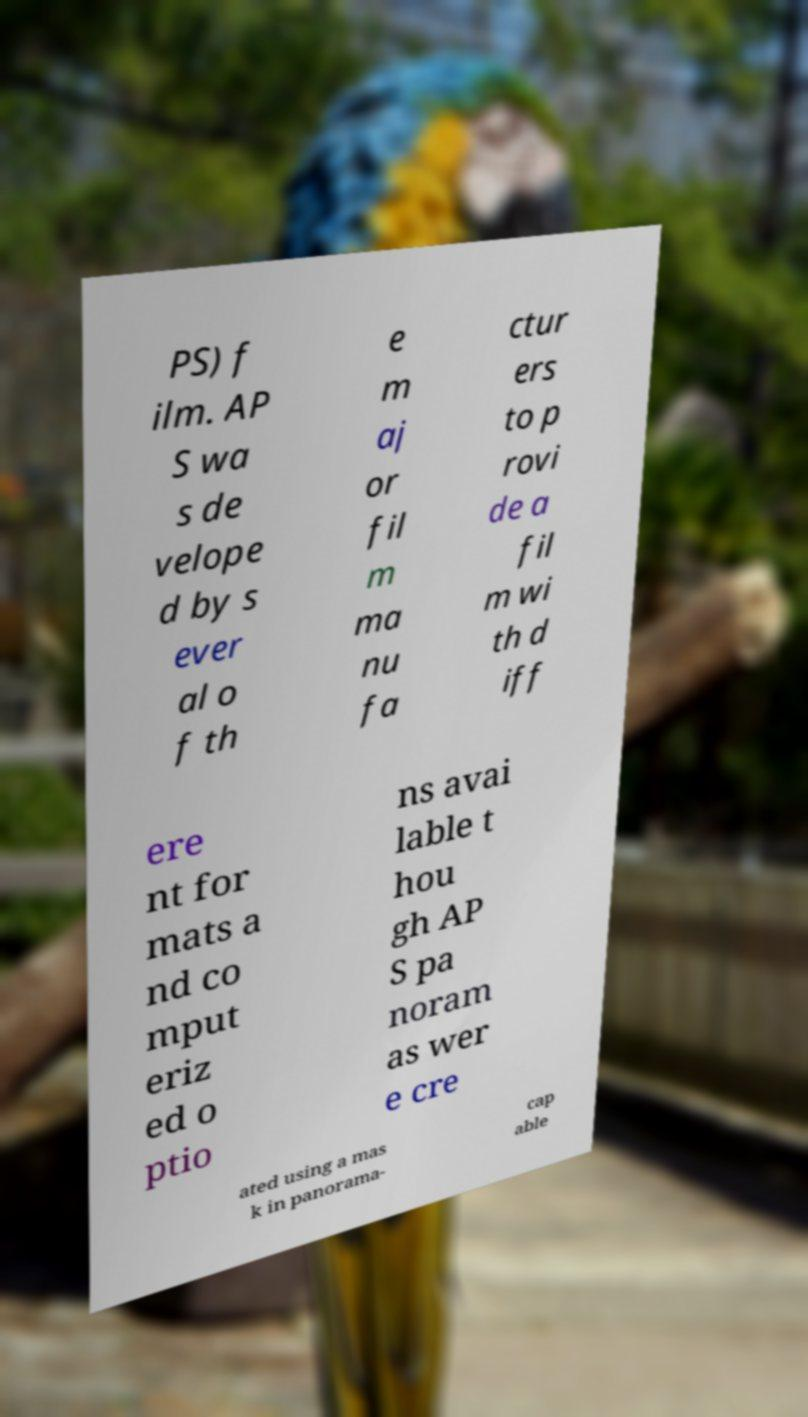There's text embedded in this image that I need extracted. Can you transcribe it verbatim? PS) f ilm. AP S wa s de velope d by s ever al o f th e m aj or fil m ma nu fa ctur ers to p rovi de a fil m wi th d iff ere nt for mats a nd co mput eriz ed o ptio ns avai lable t hou gh AP S pa noram as wer e cre ated using a mas k in panorama- cap able 